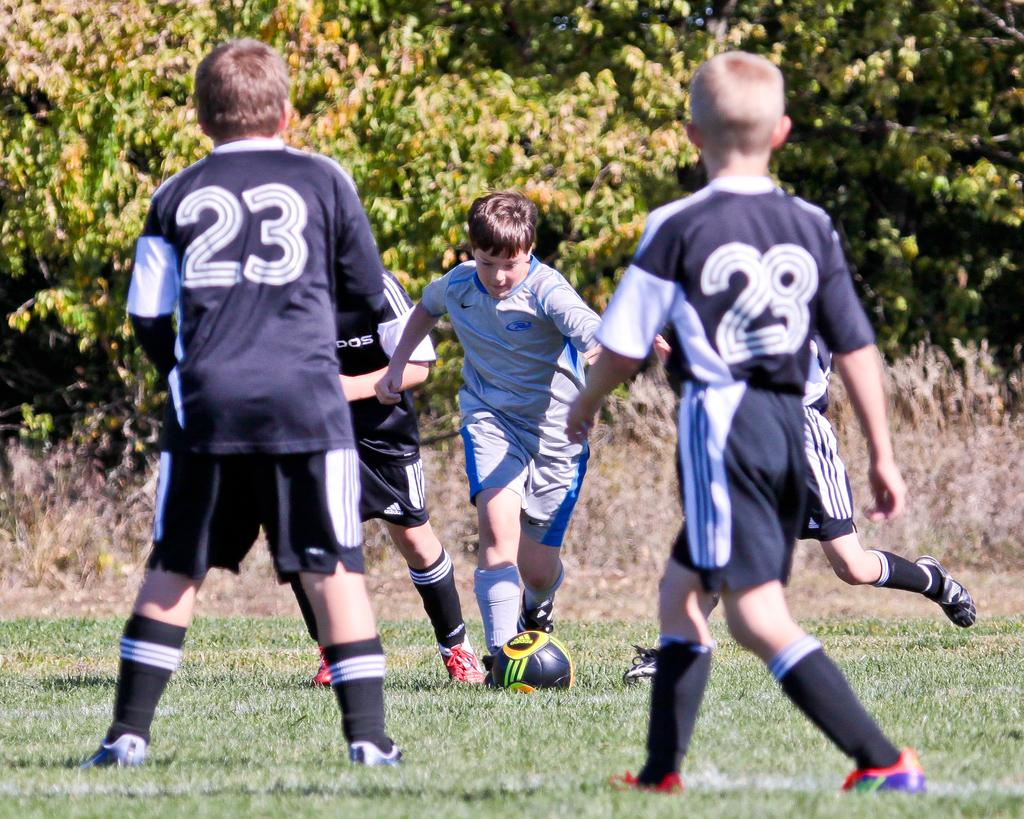How many boys are playing football in the image? There are five boys in the image. What sport are the boys playing? The boys are playing football. Where is the football located in the image? The football is on the ground. What type of surface is the football being played on? The ground is full of grass. What can be seen in the background of the image? There are trees in the background of the image. What type of copper material is being used by the boys to play football in the image? There is no copper material present in the image; the boys are playing football with a regular football. How many toes are visible on the boys' feet in the image? The number of toes cannot be determined from the image, as feet are not clearly visible. 